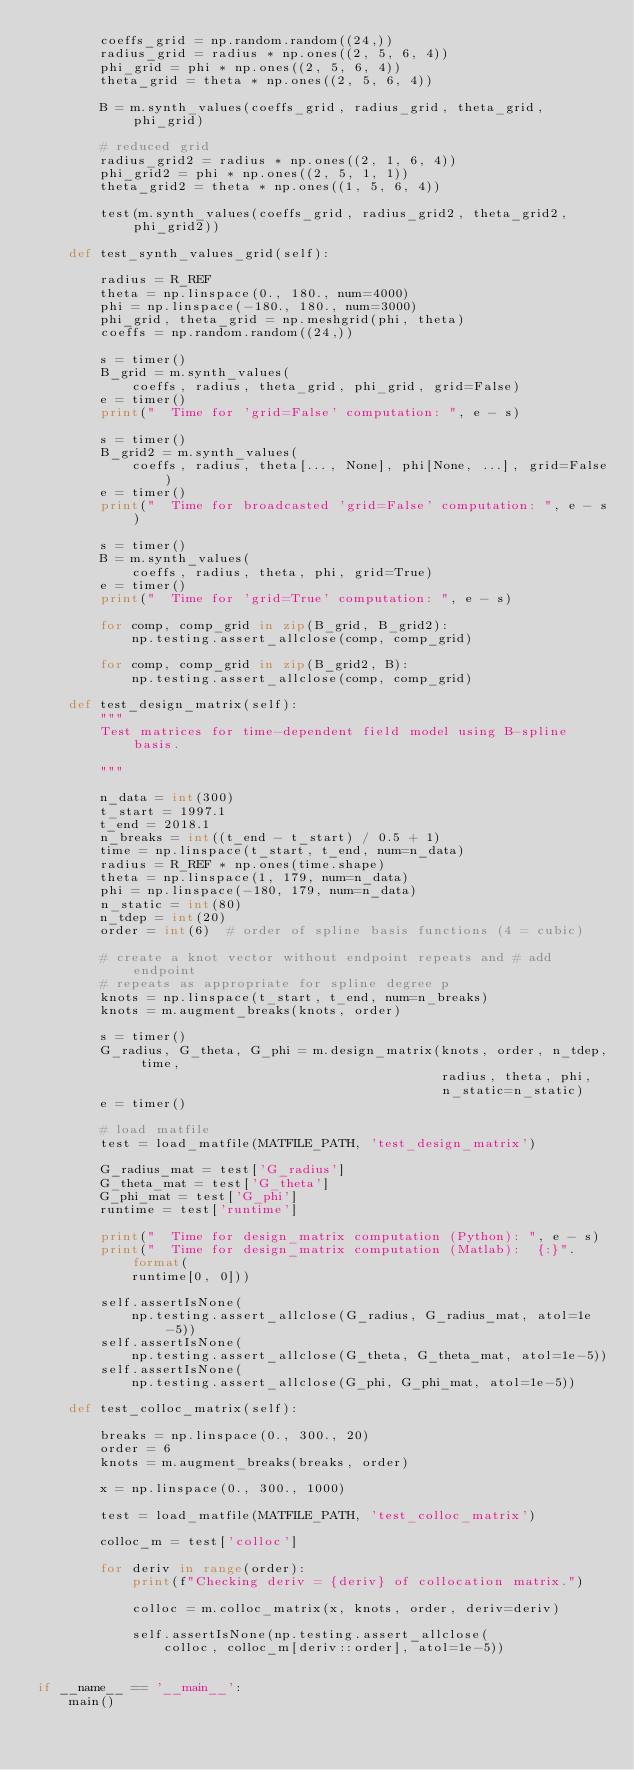<code> <loc_0><loc_0><loc_500><loc_500><_Python_>        coeffs_grid = np.random.random((24,))
        radius_grid = radius * np.ones((2, 5, 6, 4))
        phi_grid = phi * np.ones((2, 5, 6, 4))
        theta_grid = theta * np.ones((2, 5, 6, 4))

        B = m.synth_values(coeffs_grid, radius_grid, theta_grid, phi_grid)

        # reduced grid
        radius_grid2 = radius * np.ones((2, 1, 6, 4))
        phi_grid2 = phi * np.ones((2, 5, 1, 1))
        theta_grid2 = theta * np.ones((1, 5, 6, 4))

        test(m.synth_values(coeffs_grid, radius_grid2, theta_grid2, phi_grid2))

    def test_synth_values_grid(self):

        radius = R_REF
        theta = np.linspace(0., 180., num=4000)
        phi = np.linspace(-180., 180., num=3000)
        phi_grid, theta_grid = np.meshgrid(phi, theta)
        coeffs = np.random.random((24,))

        s = timer()
        B_grid = m.synth_values(
            coeffs, radius, theta_grid, phi_grid, grid=False)
        e = timer()
        print("  Time for 'grid=False' computation: ", e - s)

        s = timer()
        B_grid2 = m.synth_values(
            coeffs, radius, theta[..., None], phi[None, ...], grid=False)
        e = timer()
        print("  Time for broadcasted 'grid=False' computation: ", e - s)

        s = timer()
        B = m.synth_values(
            coeffs, radius, theta, phi, grid=True)
        e = timer()
        print("  Time for 'grid=True' computation: ", e - s)

        for comp, comp_grid in zip(B_grid, B_grid2):
            np.testing.assert_allclose(comp, comp_grid)

        for comp, comp_grid in zip(B_grid2, B):
            np.testing.assert_allclose(comp, comp_grid)

    def test_design_matrix(self):
        """
        Test matrices for time-dependent field model using B-spline basis.

        """

        n_data = int(300)
        t_start = 1997.1
        t_end = 2018.1
        n_breaks = int((t_end - t_start) / 0.5 + 1)
        time = np.linspace(t_start, t_end, num=n_data)
        radius = R_REF * np.ones(time.shape)
        theta = np.linspace(1, 179, num=n_data)
        phi = np.linspace(-180, 179, num=n_data)
        n_static = int(80)
        n_tdep = int(20)
        order = int(6)  # order of spline basis functions (4 = cubic)

        # create a knot vector without endpoint repeats and # add endpoint
        # repeats as appropriate for spline degree p
        knots = np.linspace(t_start, t_end, num=n_breaks)
        knots = m.augment_breaks(knots, order)

        s = timer()
        G_radius, G_theta, G_phi = m.design_matrix(knots, order, n_tdep, time,
                                                   radius, theta, phi,
                                                   n_static=n_static)
        e = timer()

        # load matfile
        test = load_matfile(MATFILE_PATH, 'test_design_matrix')

        G_radius_mat = test['G_radius']
        G_theta_mat = test['G_theta']
        G_phi_mat = test['G_phi']
        runtime = test['runtime']

        print("  Time for design_matrix computation (Python): ", e - s)
        print("  Time for design_matrix computation (Matlab):  {:}".format(
            runtime[0, 0]))

        self.assertIsNone(
            np.testing.assert_allclose(G_radius, G_radius_mat, atol=1e-5))
        self.assertIsNone(
            np.testing.assert_allclose(G_theta, G_theta_mat, atol=1e-5))
        self.assertIsNone(
            np.testing.assert_allclose(G_phi, G_phi_mat, atol=1e-5))

    def test_colloc_matrix(self):

        breaks = np.linspace(0., 300., 20)
        order = 6
        knots = m.augment_breaks(breaks, order)

        x = np.linspace(0., 300., 1000)

        test = load_matfile(MATFILE_PATH, 'test_colloc_matrix')

        colloc_m = test['colloc']

        for deriv in range(order):
            print(f"Checking deriv = {deriv} of collocation matrix.")

            colloc = m.colloc_matrix(x, knots, order, deriv=deriv)

            self.assertIsNone(np.testing.assert_allclose(
                colloc, colloc_m[deriv::order], atol=1e-5))


if __name__ == '__main__':
    main()
</code> 